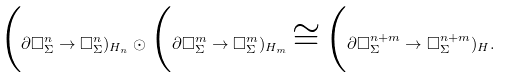Convert formula to latex. <formula><loc_0><loc_0><loc_500><loc_500>\Big ( \partial \square _ { \Sigma } ^ { n } \to \square _ { \Sigma } ^ { n } ) _ { H _ { n } } \odot \Big ( \partial \square _ { \Sigma } ^ { m } \to \square _ { \Sigma } ^ { m } ) _ { H _ { m } } \cong \Big ( \partial \square _ { \Sigma } ^ { n + m } \to \square _ { \Sigma } ^ { n + m } ) _ { H } .</formula> 